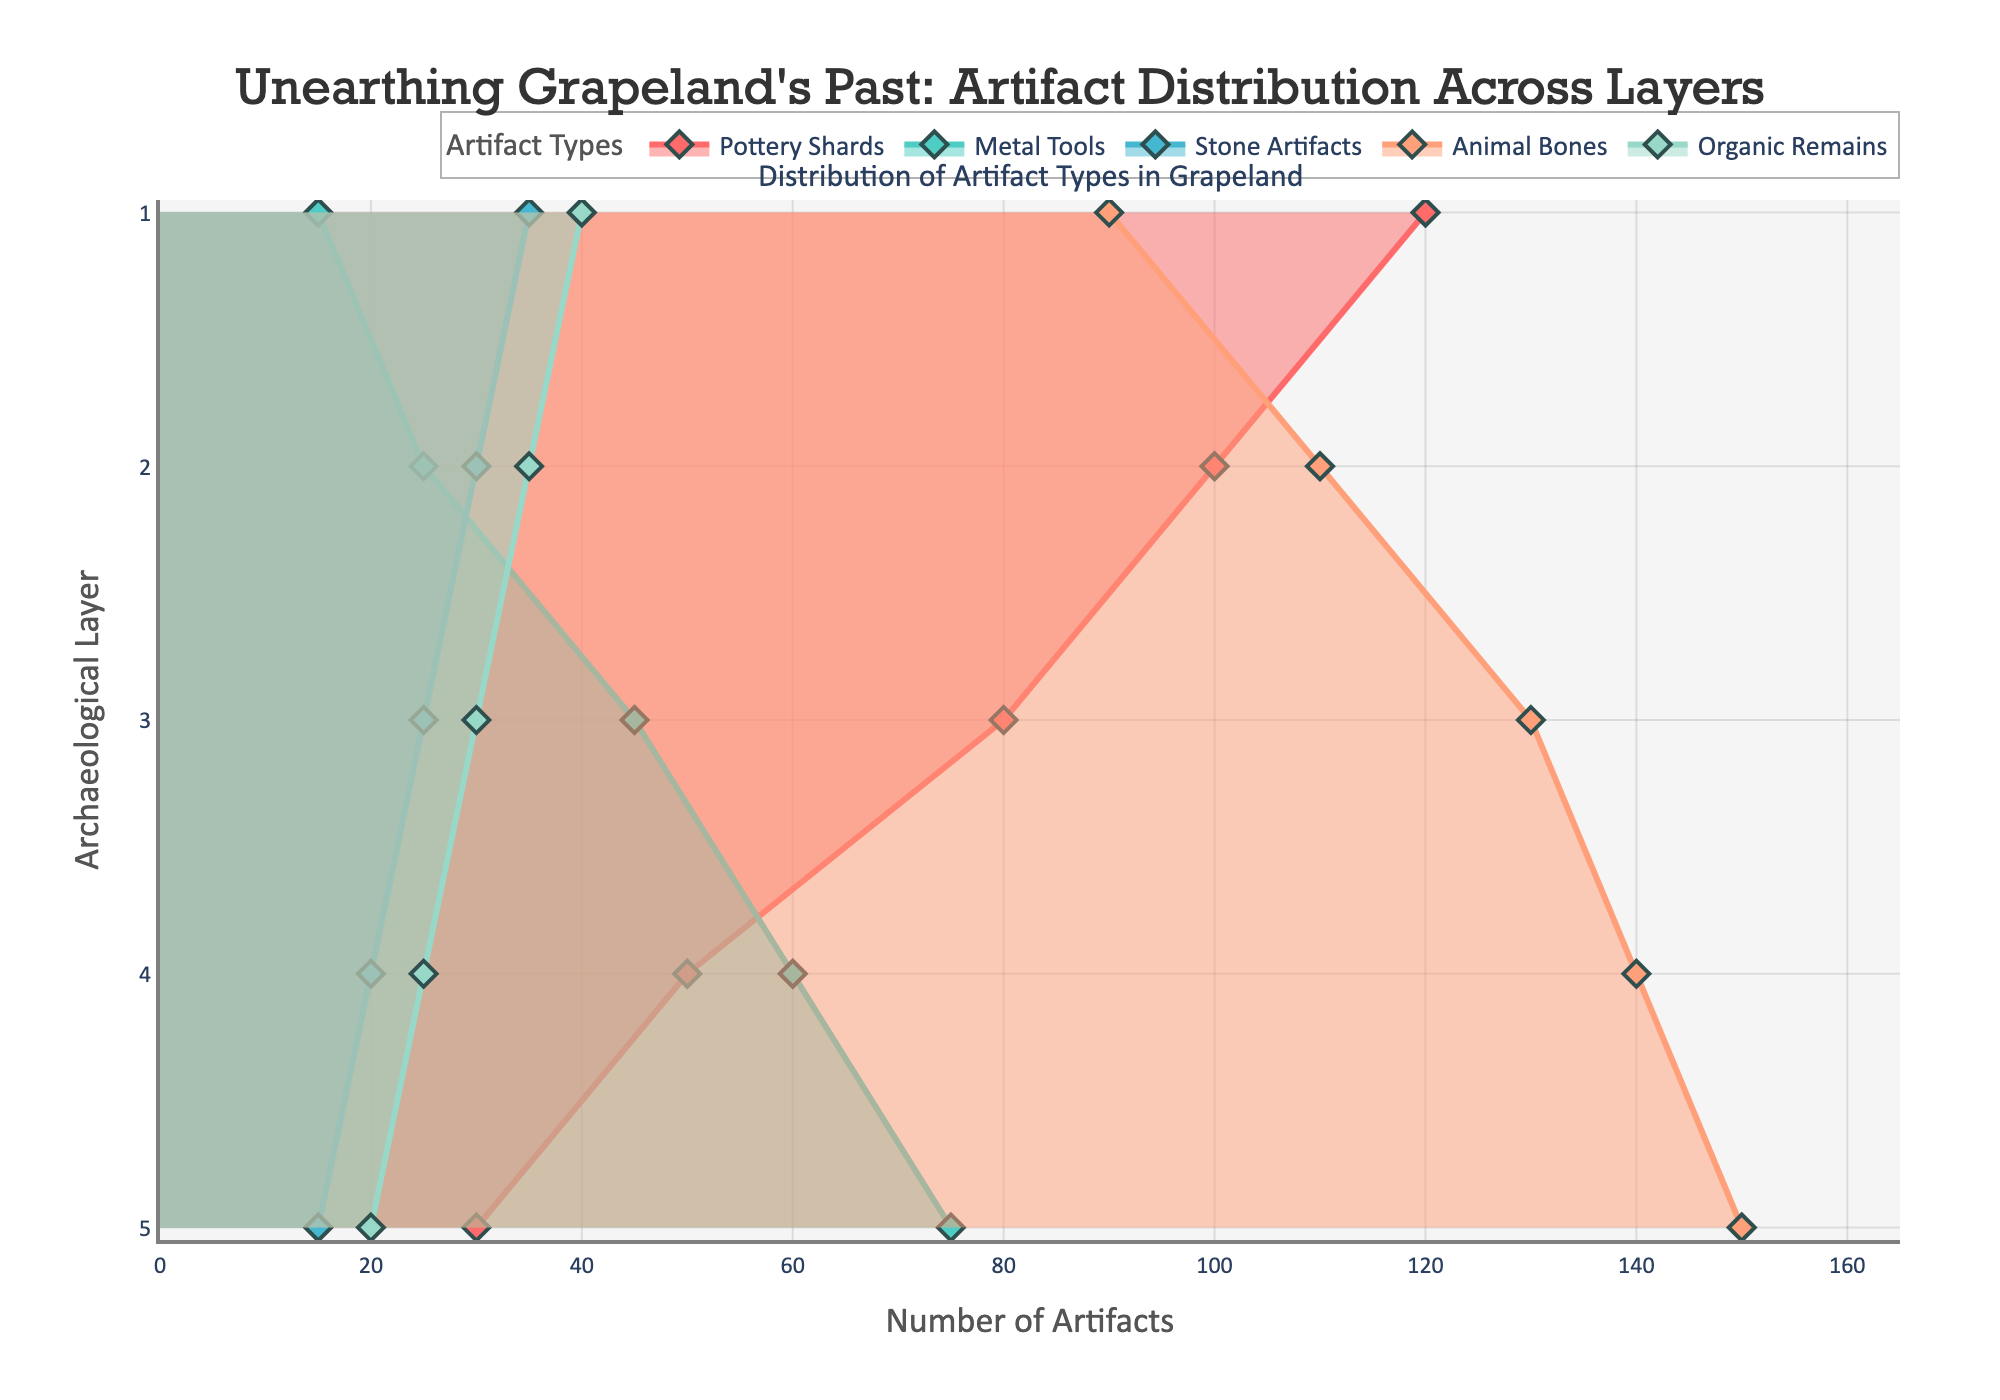What is the title of the plot? The title is prominently displayed at the top of the plot. It reads 'Unearthing Grapeland's Past: Artifact Distribution Across Layers'.
Answer: Unearthing Grapeland's Past: Artifact Distribution Across Layers Which artifact type has the highest quantity in Layer 5? The plot shows different artifact types with different colored lines. The highest quantity in Layer 5 is represented by the line that reaches the farthest to the right. In this case, it's the line for Animal Bones, which reaches up to 150 artifacts.
Answer: Animal Bones How many pottery shards were found in Layer 2? On the x-axis, find the value corresponding to "Pottery Shards" for Layer 2, which hovers around 100.
Answer: 100 Which layer contains the fewest organic remains? Look at the trend lines for "Organic Remains" across all layers. The fewest organic remains are in Layer 5, with a count of 20.
Answer: Layer 5 Compare the number of metal tools found in Layer 1 and Layer 4. Which is higher, and by how much? The figure shows that Layer 4 has 60 Metal Tools, and Layer 1 has 15 Metal Tools. Subtracting these values, we find that Layer 4 has 45 more Metal Tools than Layer 1.
Answer: Layer 4 by 45 What is the difference in the quantity of stone artifacts between Layer 2 and Layer 5? The number of Stone Artifacts in Layer 2 is 30, and in Layer 5, it is 15. The difference is 30 - 15 = 15.
Answer: 15 Which artifact type shows a consistently increasing trend as we move from Layer 1 to Layer 5? Analyze trends for all artifact types across layers. The quantity of "Metal Tools" consistently increases from Layer 1 to Layer 5.
Answer: Metal Tools What is the median number of animal bones found across all layers? The quantities of Animal Bones per layer are: 90, 110, 130, 140, and 150. Ordering these numbers, the median value is the third value in an ordered list: 130.
Answer: 130 What can you infer about the distribution of stone artifacts across layers? Observing the plot, the count for stone artifacts decreases consistently as we move from upper to lower layers, from 35 in Layer 1 to 15 in Layer 5. This indicates fewer stone artifacts were found in deeper layers.
Answer: Decreasing trend Do layers 3 and 5 have an equal number of Organic Remains? Checking the plot, both Layer 3 and Layer 5 have the same number of Organic Remains, which is 30.
Answer: Yes 